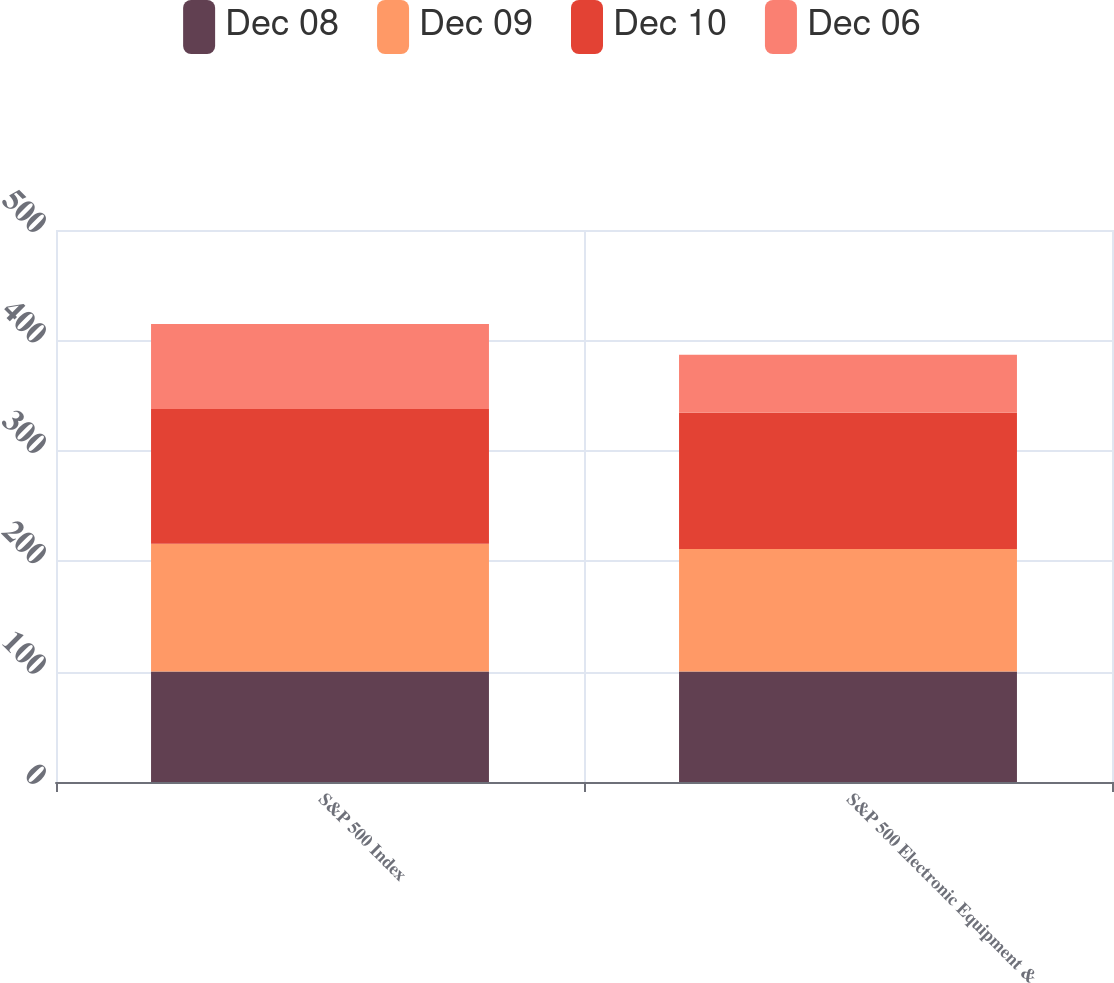Convert chart to OTSL. <chart><loc_0><loc_0><loc_500><loc_500><stacked_bar_chart><ecel><fcel>S&P 500 Index<fcel>S&P 500 Electronic Equipment &<nl><fcel>Dec 08<fcel>100<fcel>100<nl><fcel>Dec 09<fcel>115.79<fcel>110.96<nl><fcel>Dec 10<fcel>122.16<fcel>123.58<nl><fcel>Dec 06<fcel>76.96<fcel>52.57<nl></chart> 